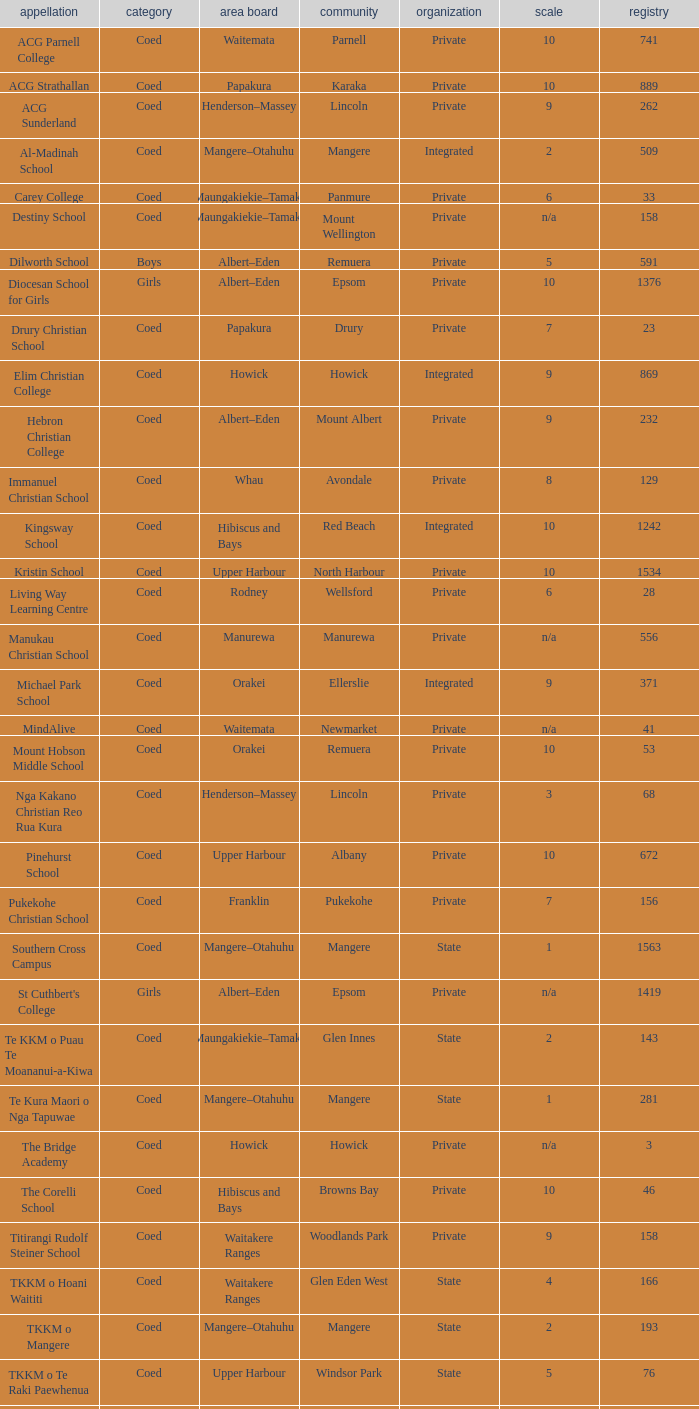What is the name of the suburb with a roll of 741? Parnell. Could you parse the entire table as a dict? {'header': ['appellation', 'category', 'area board', 'community', 'organization', 'scale', 'registry'], 'rows': [['ACG Parnell College', 'Coed', 'Waitemata', 'Parnell', 'Private', '10', '741'], ['ACG Strathallan', 'Coed', 'Papakura', 'Karaka', 'Private', '10', '889'], ['ACG Sunderland', 'Coed', 'Henderson–Massey', 'Lincoln', 'Private', '9', '262'], ['Al-Madinah School', 'Coed', 'Mangere–Otahuhu', 'Mangere', 'Integrated', '2', '509'], ['Carey College', 'Coed', 'Maungakiekie–Tamaki', 'Panmure', 'Private', '6', '33'], ['Destiny School', 'Coed', 'Maungakiekie–Tamaki', 'Mount Wellington', 'Private', 'n/a', '158'], ['Dilworth School', 'Boys', 'Albert–Eden', 'Remuera', 'Private', '5', '591'], ['Diocesan School for Girls', 'Girls', 'Albert–Eden', 'Epsom', 'Private', '10', '1376'], ['Drury Christian School', 'Coed', 'Papakura', 'Drury', 'Private', '7', '23'], ['Elim Christian College', 'Coed', 'Howick', 'Howick', 'Integrated', '9', '869'], ['Hebron Christian College', 'Coed', 'Albert–Eden', 'Mount Albert', 'Private', '9', '232'], ['Immanuel Christian School', 'Coed', 'Whau', 'Avondale', 'Private', '8', '129'], ['Kingsway School', 'Coed', 'Hibiscus and Bays', 'Red Beach', 'Integrated', '10', '1242'], ['Kristin School', 'Coed', 'Upper Harbour', 'North Harbour', 'Private', '10', '1534'], ['Living Way Learning Centre', 'Coed', 'Rodney', 'Wellsford', 'Private', '6', '28'], ['Manukau Christian School', 'Coed', 'Manurewa', 'Manurewa', 'Private', 'n/a', '556'], ['Michael Park School', 'Coed', 'Orakei', 'Ellerslie', 'Integrated', '9', '371'], ['MindAlive', 'Coed', 'Waitemata', 'Newmarket', 'Private', 'n/a', '41'], ['Mount Hobson Middle School', 'Coed', 'Orakei', 'Remuera', 'Private', '10', '53'], ['Nga Kakano Christian Reo Rua Kura', 'Coed', 'Henderson–Massey', 'Lincoln', 'Private', '3', '68'], ['Pinehurst School', 'Coed', 'Upper Harbour', 'Albany', 'Private', '10', '672'], ['Pukekohe Christian School', 'Coed', 'Franklin', 'Pukekohe', 'Private', '7', '156'], ['Southern Cross Campus', 'Coed', 'Mangere–Otahuhu', 'Mangere', 'State', '1', '1563'], ["St Cuthbert's College", 'Girls', 'Albert–Eden', 'Epsom', 'Private', 'n/a', '1419'], ['Te KKM o Puau Te Moananui-a-Kiwa', 'Coed', 'Maungakiekie–Tamaki', 'Glen Innes', 'State', '2', '143'], ['Te Kura Maori o Nga Tapuwae', 'Coed', 'Mangere–Otahuhu', 'Mangere', 'State', '1', '281'], ['The Bridge Academy', 'Coed', 'Howick', 'Howick', 'Private', 'n/a', '3'], ['The Corelli School', 'Coed', 'Hibiscus and Bays', 'Browns Bay', 'Private', '10', '46'], ['Titirangi Rudolf Steiner School', 'Coed', 'Waitakere Ranges', 'Woodlands Park', 'Private', '9', '158'], ['TKKM o Hoani Waititi', 'Coed', 'Waitakere Ranges', 'Glen Eden West', 'State', '4', '166'], ['TKKM o Mangere', 'Coed', 'Mangere–Otahuhu', 'Mangere', 'State', '2', '193'], ['TKKM o Te Raki Paewhenua', 'Coed', 'Upper Harbour', 'Windsor Park', 'State', '5', '76'], ['Tyndale Park Christian School', 'Coed', 'Howick', 'Flat Bush', 'Private', 'n/a', '120']]} 